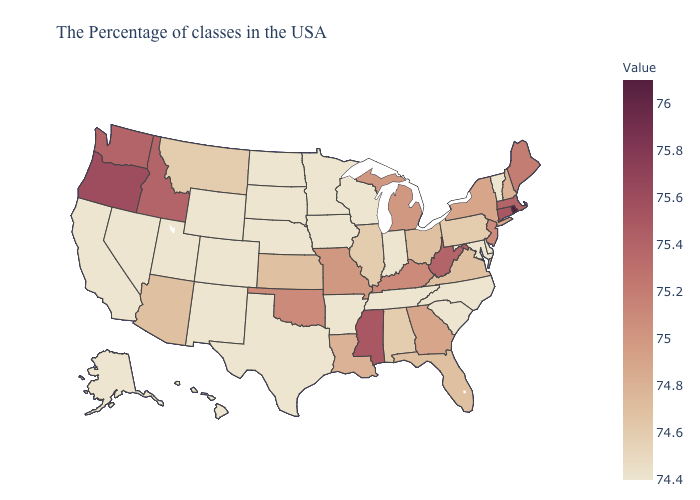Does Rhode Island have the highest value in the USA?
Keep it brief. Yes. Does Illinois have the lowest value in the USA?
Write a very short answer. No. 